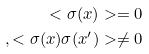<formula> <loc_0><loc_0><loc_500><loc_500>< \sigma ( x ) > = 0 \\ , < \sigma ( x ) \sigma ( x ^ { \prime } ) > \neq 0</formula> 